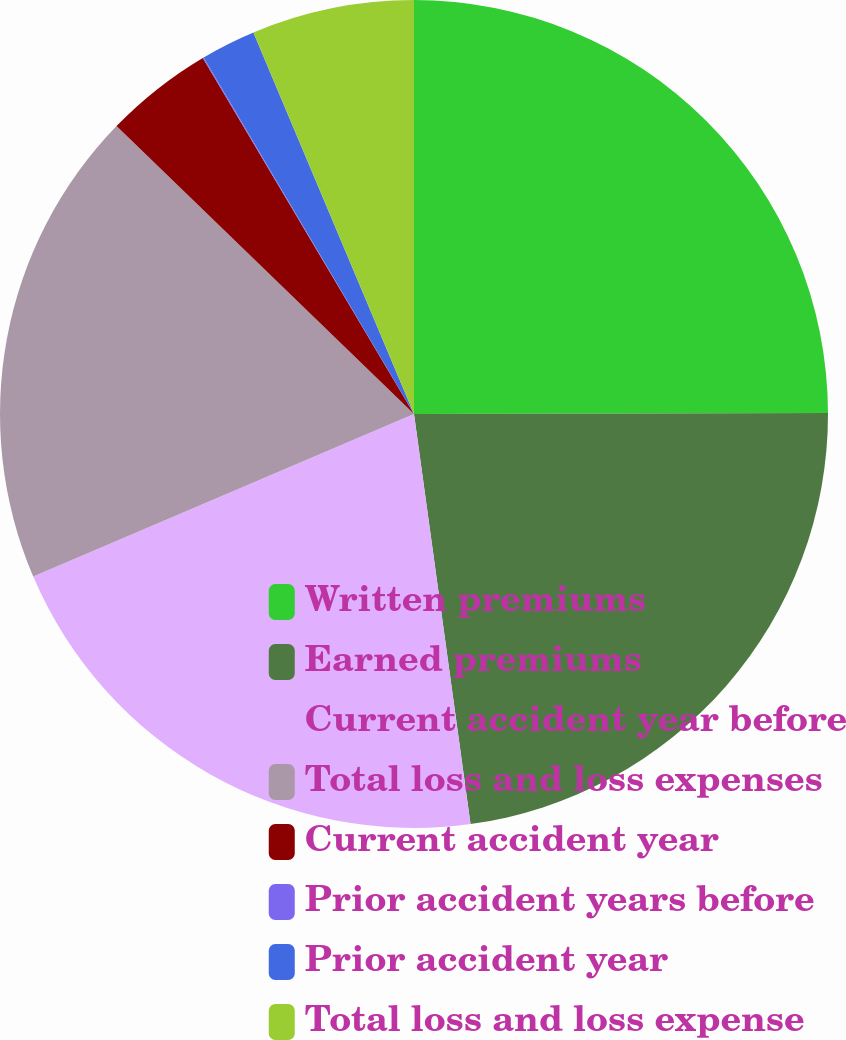<chart> <loc_0><loc_0><loc_500><loc_500><pie_chart><fcel>Written premiums<fcel>Earned premiums<fcel>Current accident year before<fcel>Total loss and loss expenses<fcel>Current accident year<fcel>Prior accident years before<fcel>Prior accident year<fcel>Total loss and loss expense<nl><fcel>24.96%<fcel>22.86%<fcel>20.76%<fcel>18.66%<fcel>4.24%<fcel>0.04%<fcel>2.14%<fcel>6.34%<nl></chart> 